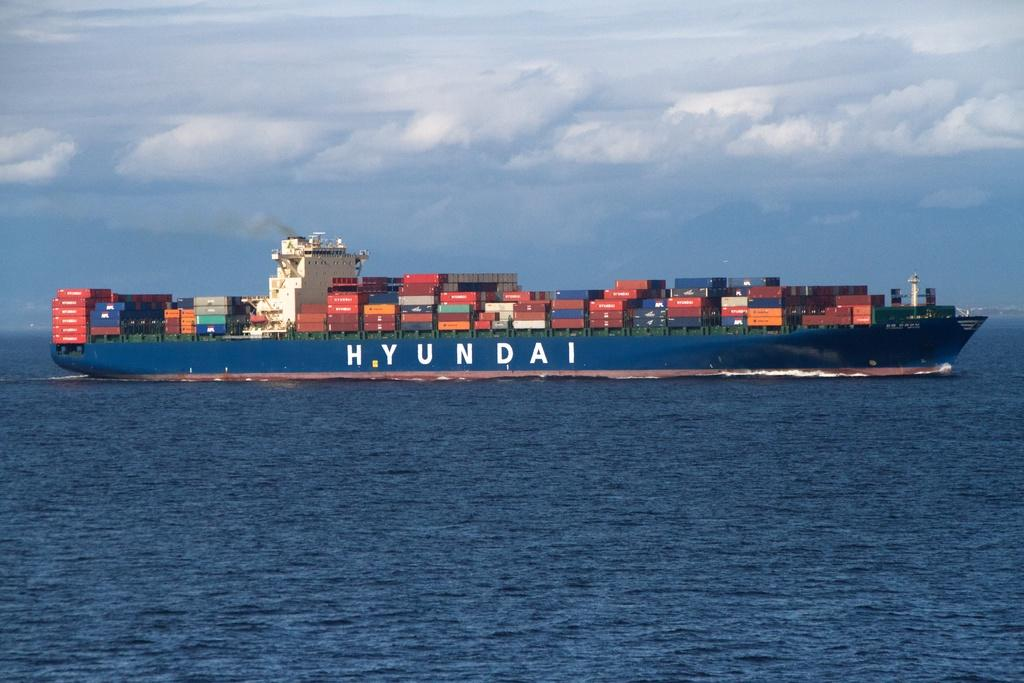What is on the ship that can be seen in the image? There are containers on the ship in the image. Where is the ship located in the image? The ship is sailing on a river in the image. What is the position of the ship in the image? The ship is in the center of the image. What can be seen in the background of the image? There is sky visible in the background of the image, and there are clouds in the sky. How many nails can be seen in the image? There are no nails present in the image. 